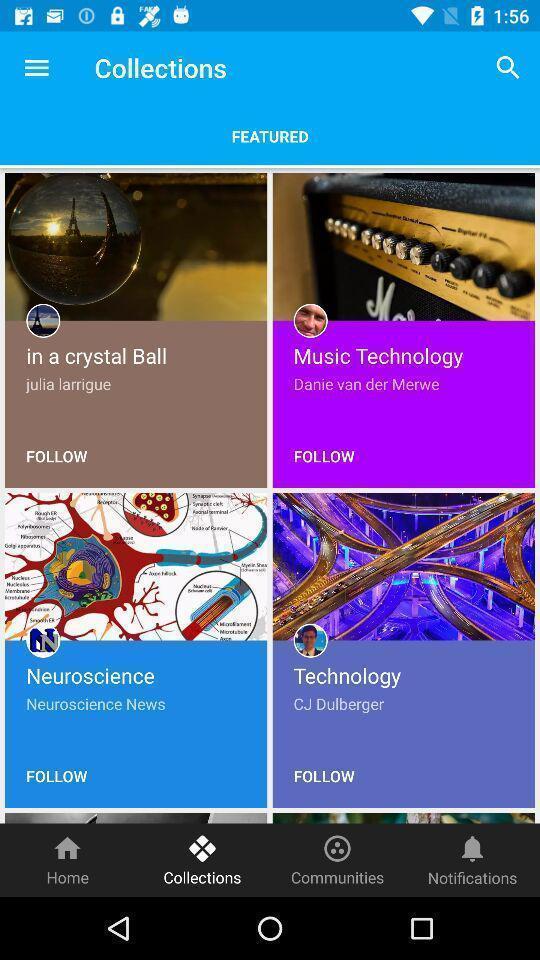Tell me what you see in this picture. Page displays different collections. 